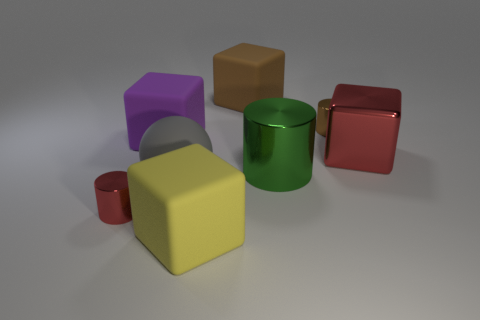Add 2 small gray spheres. How many objects exist? 10 Subtract all balls. How many objects are left? 7 Add 1 tiny red metal blocks. How many tiny red metal blocks exist? 1 Subtract 1 purple cubes. How many objects are left? 7 Subtract all metal cylinders. Subtract all red metal cylinders. How many objects are left? 4 Add 3 brown matte cubes. How many brown matte cubes are left? 4 